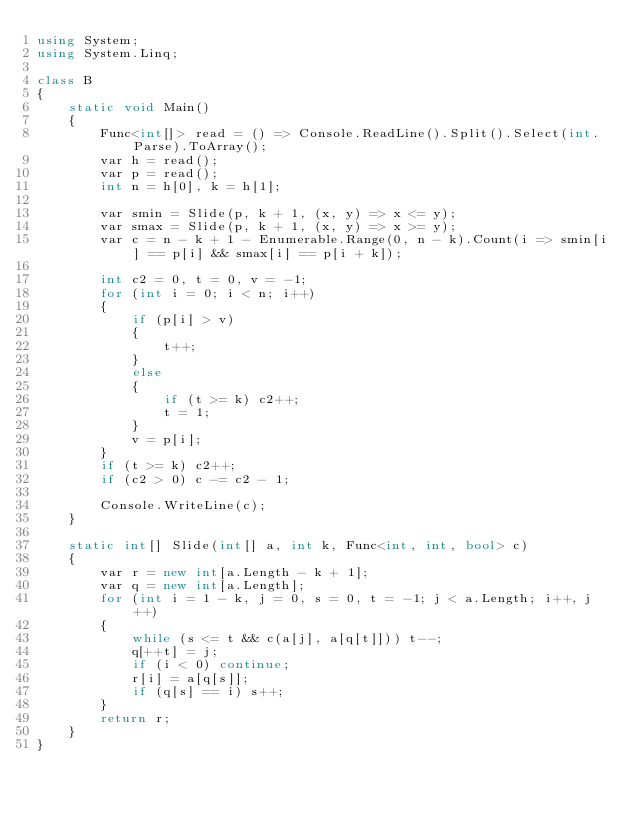<code> <loc_0><loc_0><loc_500><loc_500><_C#_>using System;
using System.Linq;

class B
{
	static void Main()
	{
		Func<int[]> read = () => Console.ReadLine().Split().Select(int.Parse).ToArray();
		var h = read();
		var p = read();
		int n = h[0], k = h[1];

		var smin = Slide(p, k + 1, (x, y) => x <= y);
		var smax = Slide(p, k + 1, (x, y) => x >= y);
		var c = n - k + 1 - Enumerable.Range(0, n - k).Count(i => smin[i] == p[i] && smax[i] == p[i + k]);

		int c2 = 0, t = 0, v = -1;
		for (int i = 0; i < n; i++)
		{
			if (p[i] > v)
			{
				t++;
			}
			else
			{
				if (t >= k) c2++;
				t = 1;
			}
			v = p[i];
		}
		if (t >= k) c2++;
		if (c2 > 0) c -= c2 - 1;

		Console.WriteLine(c);
	}

	static int[] Slide(int[] a, int k, Func<int, int, bool> c)
	{
		var r = new int[a.Length - k + 1];
		var q = new int[a.Length];
		for (int i = 1 - k, j = 0, s = 0, t = -1; j < a.Length; i++, j++)
		{
			while (s <= t && c(a[j], a[q[t]])) t--;
			q[++t] = j;
			if (i < 0) continue;
			r[i] = a[q[s]];
			if (q[s] == i) s++;
		}
		return r;
	}
}
</code> 